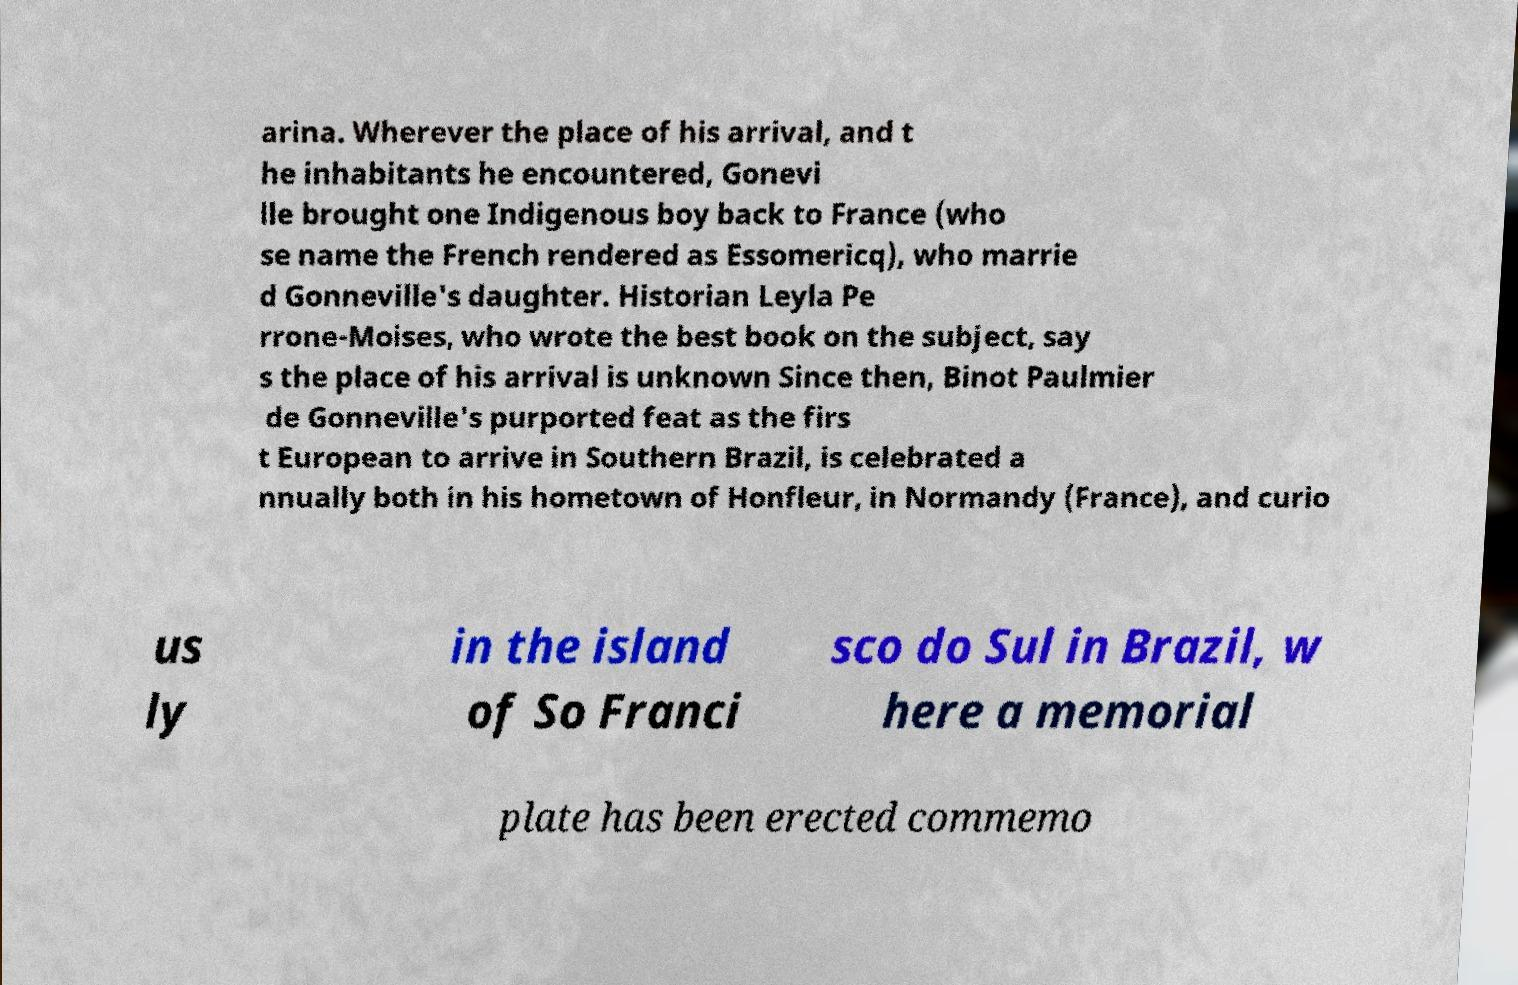Can you accurately transcribe the text from the provided image for me? arina. Wherever the place of his arrival, and t he inhabitants he encountered, Gonevi lle brought one Indigenous boy back to France (who se name the French rendered as Essomericq), who marrie d Gonneville's daughter. Historian Leyla Pe rrone-Moises, who wrote the best book on the subject, say s the place of his arrival is unknown Since then, Binot Paulmier de Gonneville's purported feat as the firs t European to arrive in Southern Brazil, is celebrated a nnually both in his hometown of Honfleur, in Normandy (France), and curio us ly in the island of So Franci sco do Sul in Brazil, w here a memorial plate has been erected commemo 